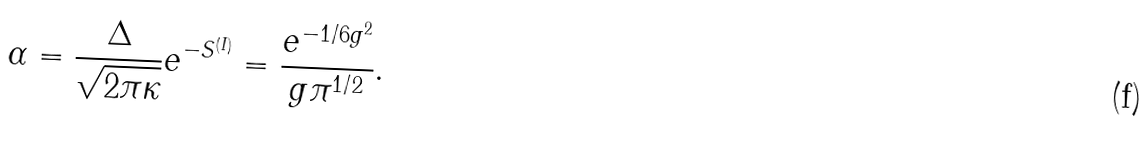<formula> <loc_0><loc_0><loc_500><loc_500>\alpha = \frac { \Delta } { \sqrt { 2 \pi \kappa } } e ^ { - S ^ { ( I ) } } = \frac { e ^ { - 1 / 6 g ^ { 2 } } } { g \pi ^ { 1 / 2 } } .</formula> 